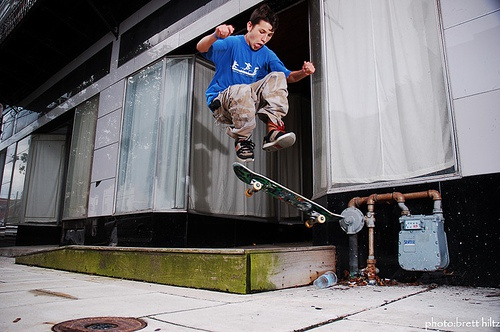Describe the objects in this image and their specific colors. I can see people in black, darkgray, blue, and gray tones, skateboard in black, gray, ivory, and darkgray tones, and cup in black, darkgray, gray, and lightblue tones in this image. 